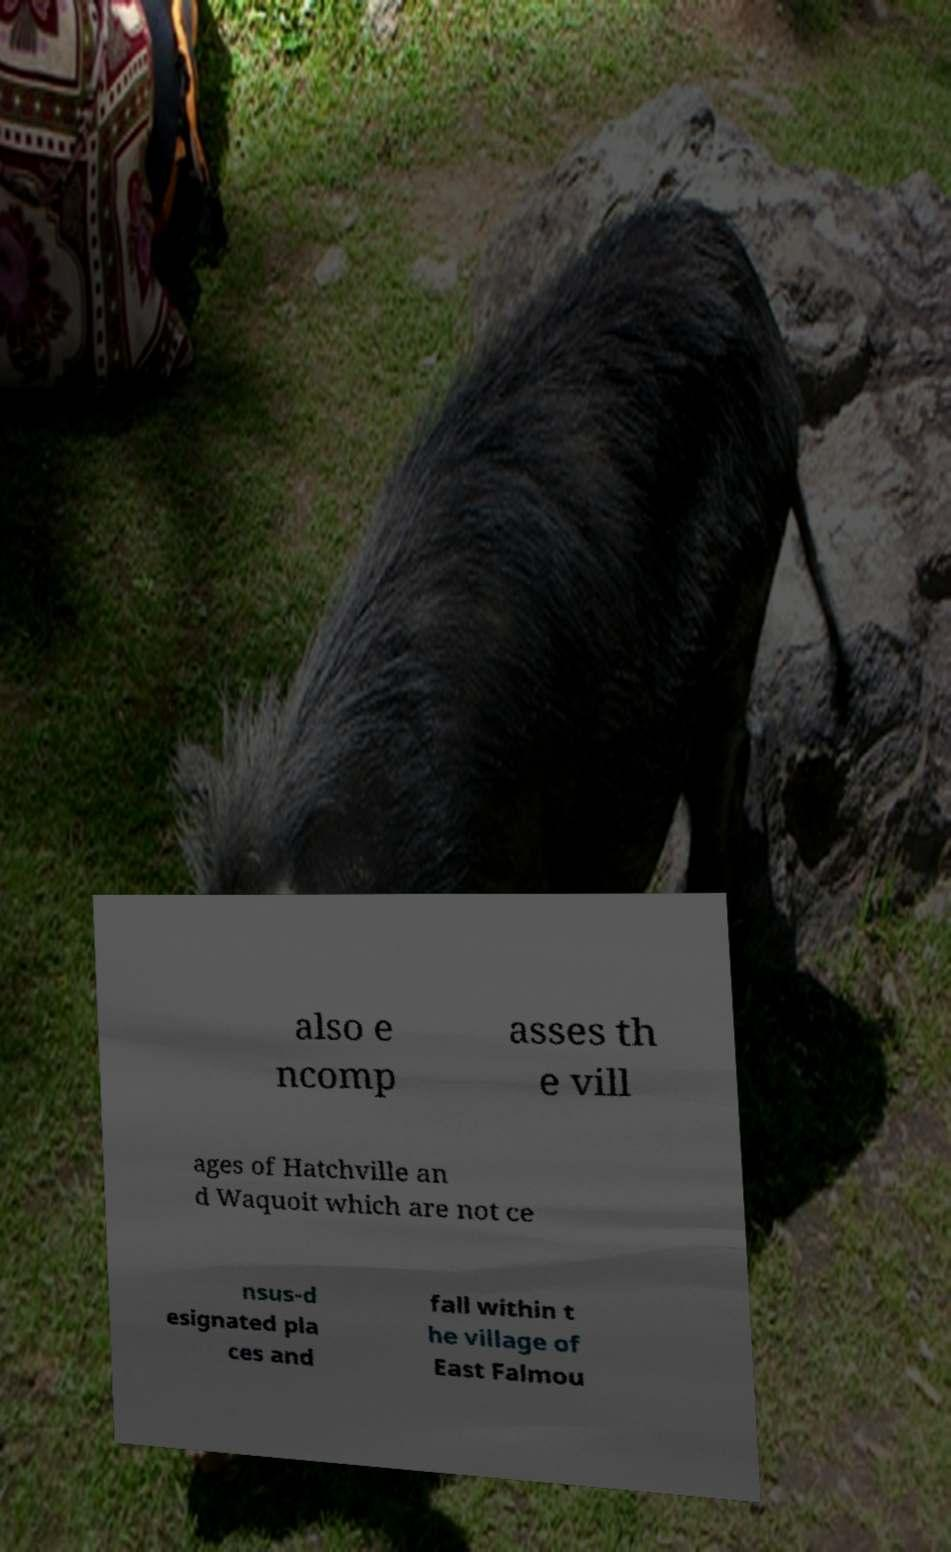Could you extract and type out the text from this image? also e ncomp asses th e vill ages of Hatchville an d Waquoit which are not ce nsus-d esignated pla ces and fall within t he village of East Falmou 